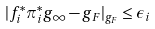Convert formula to latex. <formula><loc_0><loc_0><loc_500><loc_500>| f _ { i } ^ { * } \pi _ { i } ^ { * } g _ { \infty } - g _ { F } | _ { g _ { F } } \leq \epsilon _ { i }</formula> 